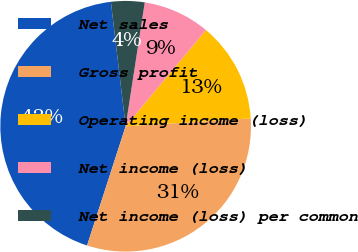<chart> <loc_0><loc_0><loc_500><loc_500><pie_chart><fcel>Net sales<fcel>Gross profit<fcel>Operating income (loss)<fcel>Net income (loss)<fcel>Net income (loss) per common<nl><fcel>43.14%<fcel>30.97%<fcel>12.94%<fcel>8.63%<fcel>4.32%<nl></chart> 